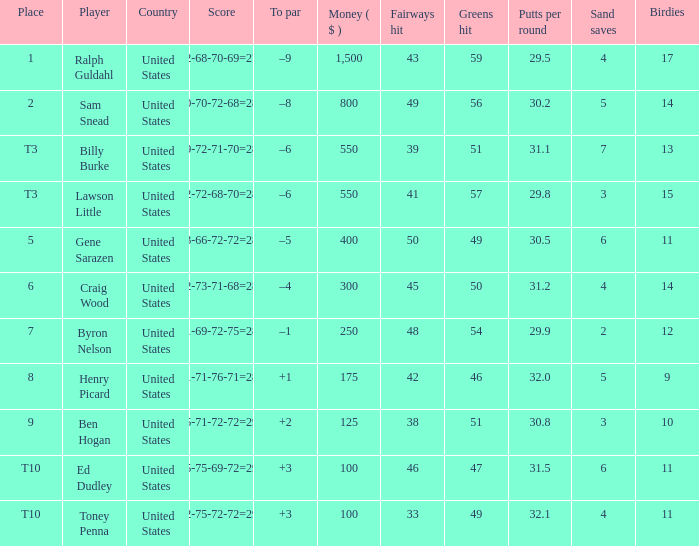Write the full table. {'header': ['Place', 'Player', 'Country', 'Score', 'To par', 'Money ( $ )', 'Fairways hit', 'Greens hit', 'Putts per round', 'Sand saves', 'Birdies'], 'rows': [['1', 'Ralph Guldahl', 'United States', '72-68-70-69=279', '–9', '1,500', '43', '59', '29.5', '4', '17'], ['2', 'Sam Snead', 'United States', '70-70-72-68=280', '–8', '800', '49', '56', '30.2', '5', '14'], ['T3', 'Billy Burke', 'United States', '69-72-71-70=282', '–6', '550', '39', '51', '31.1', '7', '13'], ['T3', 'Lawson Little', 'United States', '72-72-68-70=282', '–6', '550', '41', '57', '29.8', '3', '15'], ['5', 'Gene Sarazen', 'United States', '73-66-72-72=283', '–5', '400', '50', '49', '30.5', '6', '11'], ['6', 'Craig Wood', 'United States', '72-73-71-68=284', '–4', '300', '45', '50', '31.2', '4', '14'], ['7', 'Byron Nelson', 'United States', '71-69-72-75=287', '–1', '250', '48', '54', '29.9', '2', '12'], ['8', 'Henry Picard', 'United States', '71-71-76-71=289', '+1', '175', '42', '46', '32.0', '5', '9'], ['9', 'Ben Hogan', 'United States', '75-71-72-72=290', '+2', '125', '38', '51', '30.8', '3', '10'], ['T10', 'Ed Dudley', 'United States', '75-75-69-72=291', '+3', '100', '46', '47', '31.5', '6', '11'], ['T10', 'Toney Penna', 'United States', '72-75-72-72=291', '+3', '100', '33', '49', '32.1', '4', '11']]} Which to par has a prize less than $800? –8. 